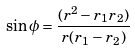Convert formula to latex. <formula><loc_0><loc_0><loc_500><loc_500>\sin \phi = \frac { ( r ^ { 2 } - r _ { 1 } r _ { 2 } ) } { r ( r _ { 1 } - r _ { 2 } ) }</formula> 